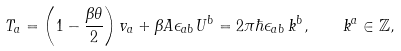Convert formula to latex. <formula><loc_0><loc_0><loc_500><loc_500>T _ { a } = \left ( 1 - \frac { \beta \theta } { 2 } \right ) v _ { a } + \beta A \epsilon _ { a b } U ^ { b } = 2 \pi \hbar { \epsilon } _ { a b } \, k ^ { b } , \quad k ^ { a } \in \mathbb { Z } ,</formula> 